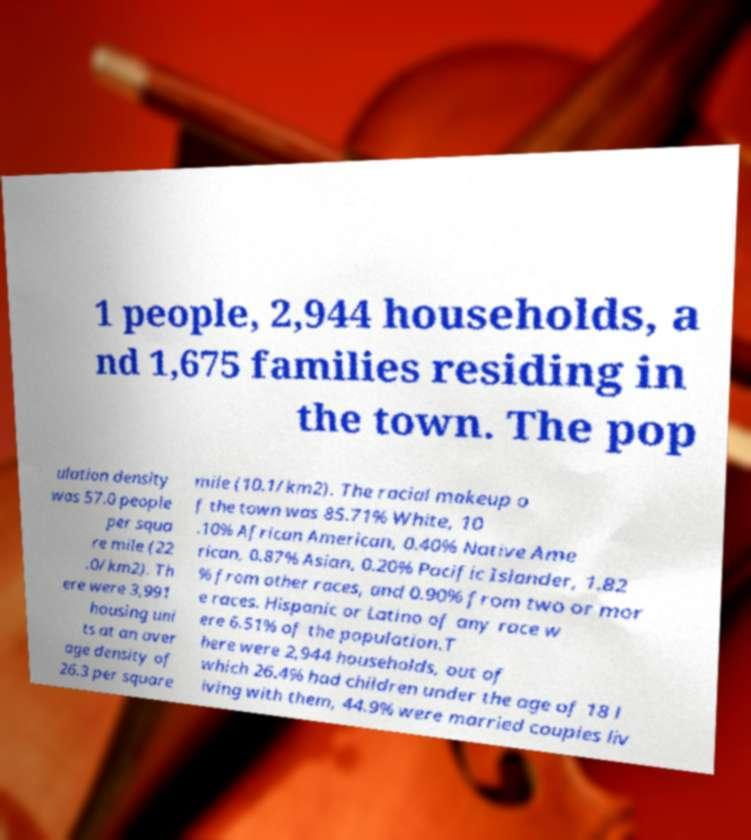Could you extract and type out the text from this image? 1 people, 2,944 households, a nd 1,675 families residing in the town. The pop ulation density was 57.0 people per squa re mile (22 .0/km2). Th ere were 3,991 housing uni ts at an aver age density of 26.3 per square mile (10.1/km2). The racial makeup o f the town was 85.71% White, 10 .10% African American, 0.40% Native Ame rican, 0.87% Asian, 0.20% Pacific Islander, 1.82 % from other races, and 0.90% from two or mor e races. Hispanic or Latino of any race w ere 6.51% of the population.T here were 2,944 households, out of which 26.4% had children under the age of 18 l iving with them, 44.9% were married couples liv 